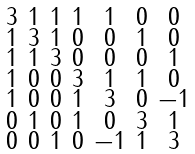<formula> <loc_0><loc_0><loc_500><loc_500>\begin{smallmatrix} 3 & 1 & 1 & 1 & 1 & 0 & 0 \\ 1 & 3 & 1 & 0 & 0 & 1 & 0 \\ 1 & 1 & 3 & 0 & 0 & 0 & 1 \\ 1 & 0 & 0 & 3 & 1 & 1 & 0 \\ 1 & 0 & 0 & 1 & 3 & 0 & - 1 \\ 0 & 1 & 0 & 1 & 0 & 3 & 1 \\ 0 & 0 & 1 & 0 & - 1 & 1 & 3 \end{smallmatrix}</formula> 